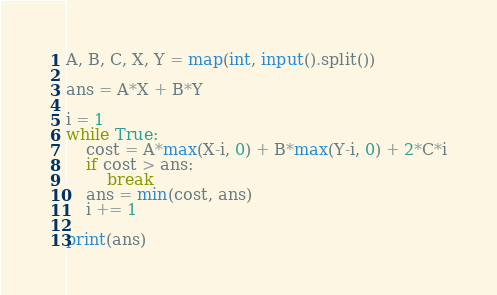<code> <loc_0><loc_0><loc_500><loc_500><_Python_>A, B, C, X, Y = map(int, input().split())

ans = A*X + B*Y

i = 1
while True:
    cost = A*max(X-i, 0) + B*max(Y-i, 0) + 2*C*i
    if cost > ans:
        break
    ans = min(cost, ans)
    i += 1

print(ans)</code> 